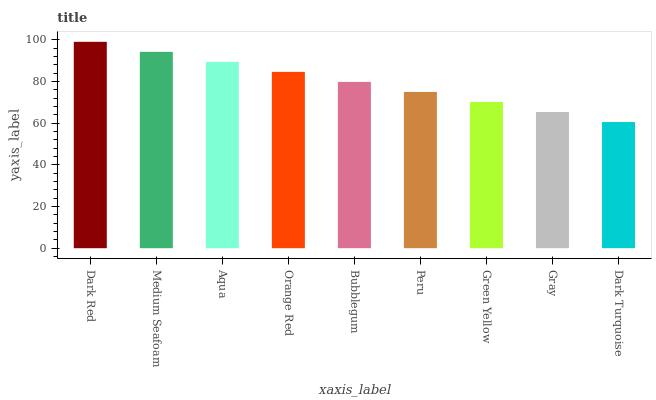Is Dark Turquoise the minimum?
Answer yes or no. Yes. Is Dark Red the maximum?
Answer yes or no. Yes. Is Medium Seafoam the minimum?
Answer yes or no. No. Is Medium Seafoam the maximum?
Answer yes or no. No. Is Dark Red greater than Medium Seafoam?
Answer yes or no. Yes. Is Medium Seafoam less than Dark Red?
Answer yes or no. Yes. Is Medium Seafoam greater than Dark Red?
Answer yes or no. No. Is Dark Red less than Medium Seafoam?
Answer yes or no. No. Is Bubblegum the high median?
Answer yes or no. Yes. Is Bubblegum the low median?
Answer yes or no. Yes. Is Gray the high median?
Answer yes or no. No. Is Orange Red the low median?
Answer yes or no. No. 